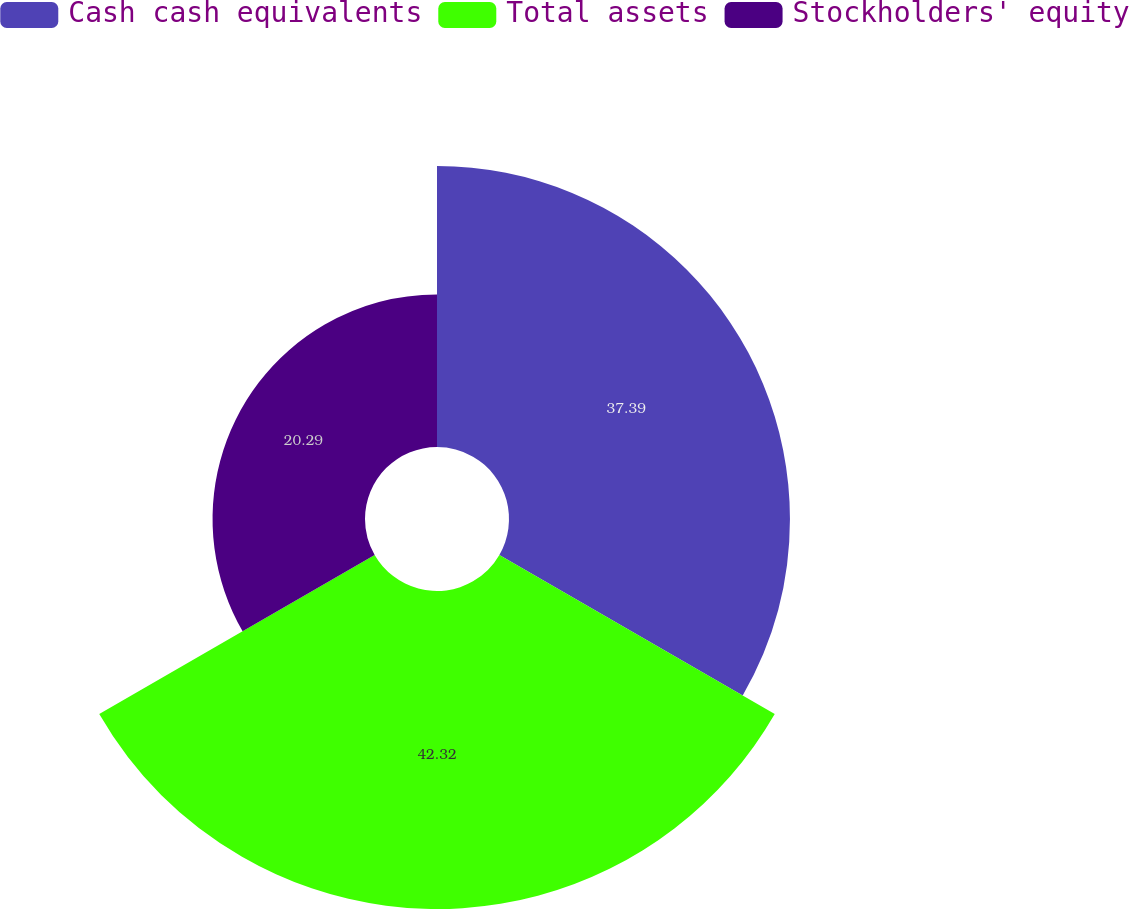Convert chart to OTSL. <chart><loc_0><loc_0><loc_500><loc_500><pie_chart><fcel>Cash cash equivalents<fcel>Total assets<fcel>Stockholders' equity<nl><fcel>37.39%<fcel>42.32%<fcel>20.29%<nl></chart> 